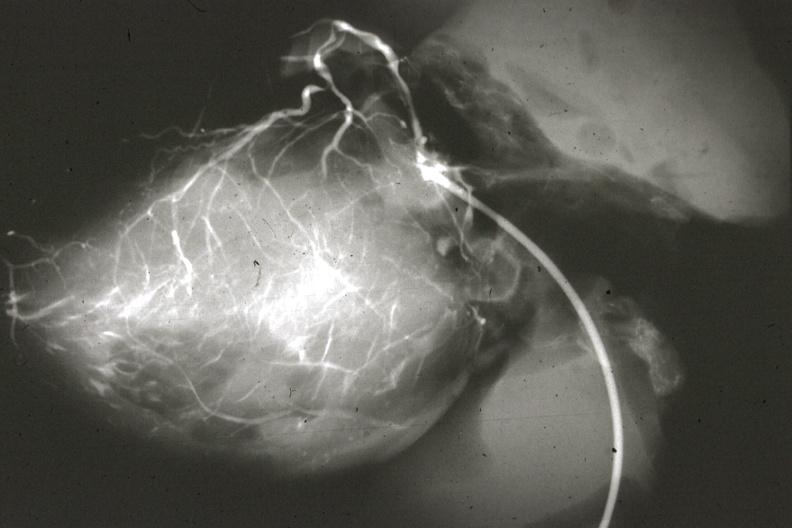does this image show angiogram postmortafter switch of left coronary to aorta?
Answer the question using a single word or phrase. Yes 